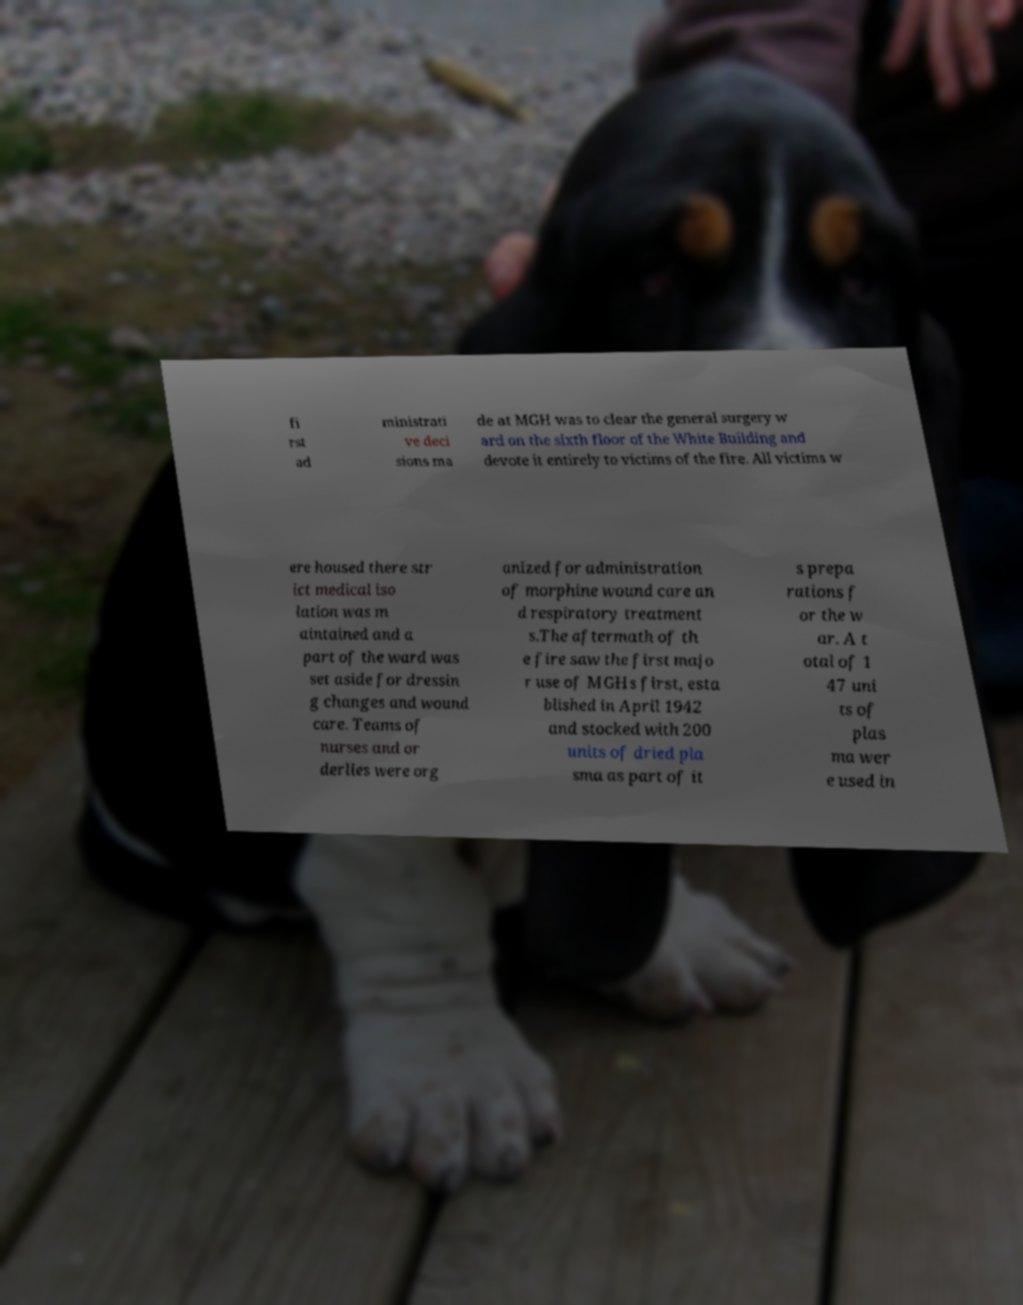Can you accurately transcribe the text from the provided image for me? fi rst ad ministrati ve deci sions ma de at MGH was to clear the general surgery w ard on the sixth floor of the White Building and devote it entirely to victims of the fire. All victims w ere housed there str ict medical iso lation was m aintained and a part of the ward was set aside for dressin g changes and wound care. Teams of nurses and or derlies were org anized for administration of morphine wound care an d respiratory treatment s.The aftermath of th e fire saw the first majo r use of MGHs first, esta blished in April 1942 and stocked with 200 units of dried pla sma as part of it s prepa rations f or the w ar. A t otal of 1 47 uni ts of plas ma wer e used in 